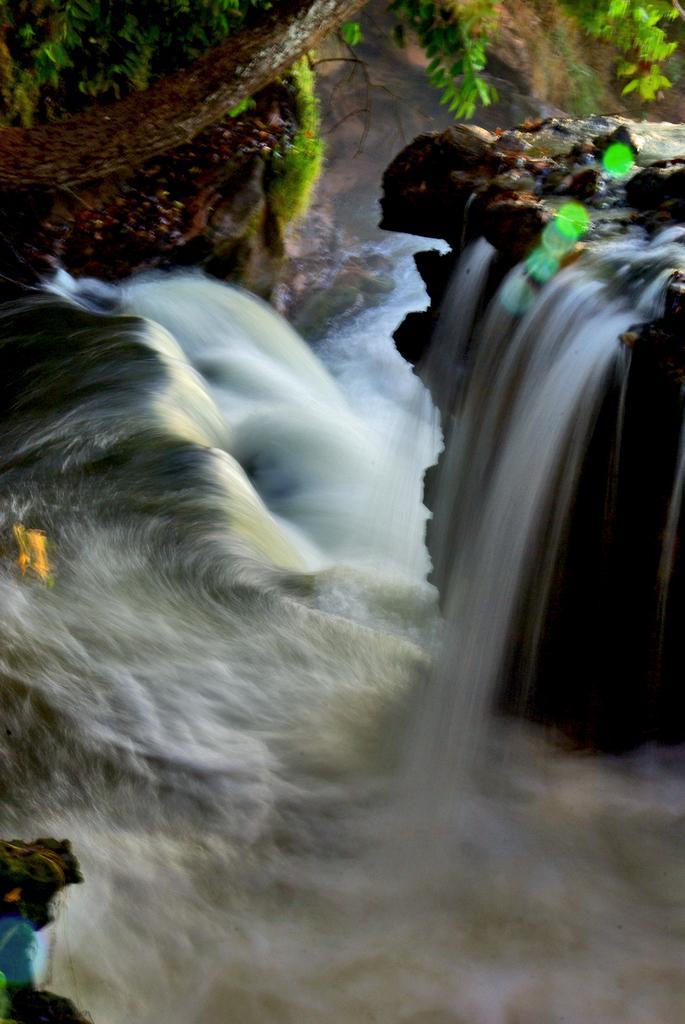In one or two sentences, can you explain what this image depicts? In this picture there is a waterfall. At the back there is a tree. At the bottom there is water. 